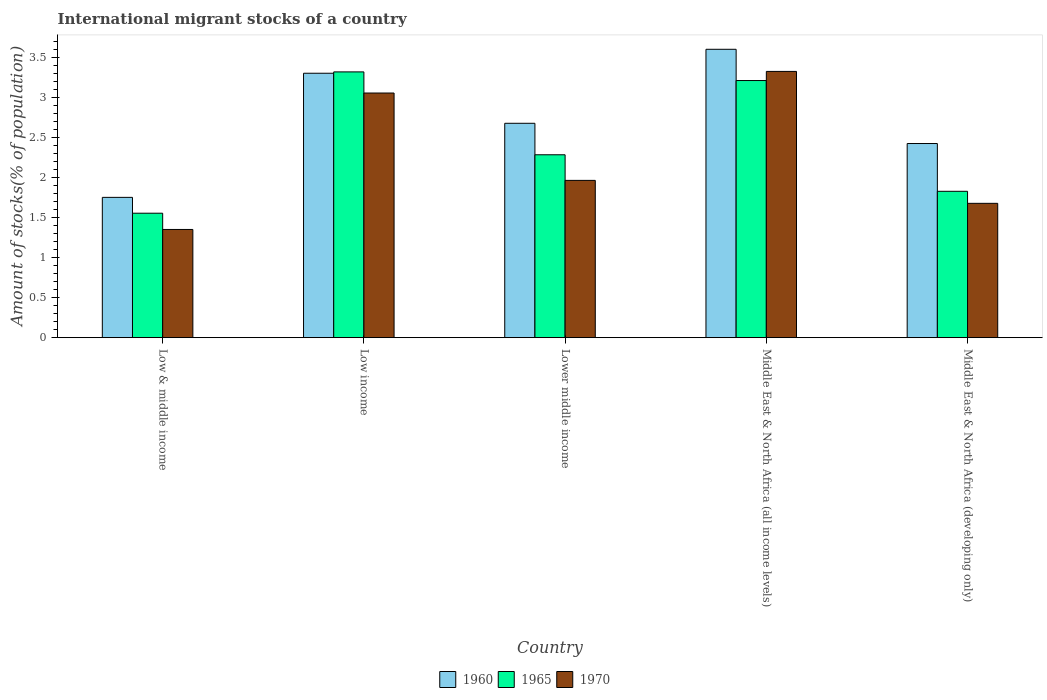How many groups of bars are there?
Give a very brief answer. 5. How many bars are there on the 5th tick from the right?
Provide a succinct answer. 3. In how many cases, is the number of bars for a given country not equal to the number of legend labels?
Offer a very short reply. 0. What is the amount of stocks in in 1965 in Low & middle income?
Your answer should be very brief. 1.56. Across all countries, what is the maximum amount of stocks in in 1970?
Provide a short and direct response. 3.33. Across all countries, what is the minimum amount of stocks in in 1965?
Offer a terse response. 1.56. In which country was the amount of stocks in in 1960 maximum?
Provide a succinct answer. Middle East & North Africa (all income levels). In which country was the amount of stocks in in 1970 minimum?
Your answer should be compact. Low & middle income. What is the total amount of stocks in in 1970 in the graph?
Offer a very short reply. 11.38. What is the difference between the amount of stocks in in 1965 in Lower middle income and that in Middle East & North Africa (all income levels)?
Provide a succinct answer. -0.93. What is the difference between the amount of stocks in in 1970 in Low & middle income and the amount of stocks in in 1965 in Low income?
Offer a terse response. -1.97. What is the average amount of stocks in in 1960 per country?
Your answer should be very brief. 2.75. What is the difference between the amount of stocks in of/in 1960 and amount of stocks in of/in 1970 in Middle East & North Africa (all income levels)?
Your answer should be compact. 0.28. In how many countries, is the amount of stocks in in 1965 greater than 2.1 %?
Your response must be concise. 3. What is the ratio of the amount of stocks in in 1970 in Middle East & North Africa (all income levels) to that in Middle East & North Africa (developing only)?
Offer a terse response. 1.98. What is the difference between the highest and the second highest amount of stocks in in 1960?
Offer a terse response. 0.63. What is the difference between the highest and the lowest amount of stocks in in 1970?
Offer a terse response. 1.98. What does the 2nd bar from the left in Low & middle income represents?
Provide a succinct answer. 1965. What does the 2nd bar from the right in Middle East & North Africa (all income levels) represents?
Offer a very short reply. 1965. Is it the case that in every country, the sum of the amount of stocks in in 1960 and amount of stocks in in 1970 is greater than the amount of stocks in in 1965?
Keep it short and to the point. Yes. How many bars are there?
Ensure brevity in your answer.  15. What is the difference between two consecutive major ticks on the Y-axis?
Give a very brief answer. 0.5. Does the graph contain grids?
Your answer should be compact. No. What is the title of the graph?
Your answer should be compact. International migrant stocks of a country. Does "2004" appear as one of the legend labels in the graph?
Provide a short and direct response. No. What is the label or title of the X-axis?
Provide a short and direct response. Country. What is the label or title of the Y-axis?
Provide a short and direct response. Amount of stocks(% of population). What is the Amount of stocks(% of population) of 1960 in Low & middle income?
Keep it short and to the point. 1.75. What is the Amount of stocks(% of population) in 1965 in Low & middle income?
Make the answer very short. 1.56. What is the Amount of stocks(% of population) of 1970 in Low & middle income?
Offer a terse response. 1.35. What is the Amount of stocks(% of population) of 1960 in Low income?
Provide a succinct answer. 3.31. What is the Amount of stocks(% of population) of 1965 in Low income?
Your answer should be very brief. 3.32. What is the Amount of stocks(% of population) in 1970 in Low income?
Your response must be concise. 3.06. What is the Amount of stocks(% of population) of 1960 in Lower middle income?
Keep it short and to the point. 2.68. What is the Amount of stocks(% of population) in 1965 in Lower middle income?
Your response must be concise. 2.29. What is the Amount of stocks(% of population) of 1970 in Lower middle income?
Your response must be concise. 1.97. What is the Amount of stocks(% of population) in 1960 in Middle East & North Africa (all income levels)?
Make the answer very short. 3.6. What is the Amount of stocks(% of population) of 1965 in Middle East & North Africa (all income levels)?
Offer a very short reply. 3.21. What is the Amount of stocks(% of population) in 1970 in Middle East & North Africa (all income levels)?
Offer a terse response. 3.33. What is the Amount of stocks(% of population) in 1960 in Middle East & North Africa (developing only)?
Offer a very short reply. 2.43. What is the Amount of stocks(% of population) of 1965 in Middle East & North Africa (developing only)?
Offer a terse response. 1.83. What is the Amount of stocks(% of population) of 1970 in Middle East & North Africa (developing only)?
Provide a succinct answer. 1.68. Across all countries, what is the maximum Amount of stocks(% of population) of 1960?
Offer a terse response. 3.6. Across all countries, what is the maximum Amount of stocks(% of population) of 1965?
Provide a succinct answer. 3.32. Across all countries, what is the maximum Amount of stocks(% of population) of 1970?
Keep it short and to the point. 3.33. Across all countries, what is the minimum Amount of stocks(% of population) in 1960?
Ensure brevity in your answer.  1.75. Across all countries, what is the minimum Amount of stocks(% of population) in 1965?
Provide a succinct answer. 1.56. Across all countries, what is the minimum Amount of stocks(% of population) of 1970?
Offer a terse response. 1.35. What is the total Amount of stocks(% of population) of 1960 in the graph?
Provide a succinct answer. 13.77. What is the total Amount of stocks(% of population) of 1965 in the graph?
Your response must be concise. 12.21. What is the total Amount of stocks(% of population) in 1970 in the graph?
Offer a terse response. 11.38. What is the difference between the Amount of stocks(% of population) in 1960 in Low & middle income and that in Low income?
Provide a succinct answer. -1.55. What is the difference between the Amount of stocks(% of population) in 1965 in Low & middle income and that in Low income?
Your answer should be compact. -1.77. What is the difference between the Amount of stocks(% of population) of 1970 in Low & middle income and that in Low income?
Provide a succinct answer. -1.71. What is the difference between the Amount of stocks(% of population) in 1960 in Low & middle income and that in Lower middle income?
Provide a short and direct response. -0.93. What is the difference between the Amount of stocks(% of population) of 1965 in Low & middle income and that in Lower middle income?
Offer a terse response. -0.73. What is the difference between the Amount of stocks(% of population) in 1970 in Low & middle income and that in Lower middle income?
Offer a very short reply. -0.61. What is the difference between the Amount of stocks(% of population) in 1960 in Low & middle income and that in Middle East & North Africa (all income levels)?
Your response must be concise. -1.85. What is the difference between the Amount of stocks(% of population) of 1965 in Low & middle income and that in Middle East & North Africa (all income levels)?
Offer a terse response. -1.66. What is the difference between the Amount of stocks(% of population) in 1970 in Low & middle income and that in Middle East & North Africa (all income levels)?
Keep it short and to the point. -1.98. What is the difference between the Amount of stocks(% of population) in 1960 in Low & middle income and that in Middle East & North Africa (developing only)?
Give a very brief answer. -0.67. What is the difference between the Amount of stocks(% of population) in 1965 in Low & middle income and that in Middle East & North Africa (developing only)?
Give a very brief answer. -0.27. What is the difference between the Amount of stocks(% of population) in 1970 in Low & middle income and that in Middle East & North Africa (developing only)?
Ensure brevity in your answer.  -0.33. What is the difference between the Amount of stocks(% of population) of 1960 in Low income and that in Lower middle income?
Give a very brief answer. 0.63. What is the difference between the Amount of stocks(% of population) of 1965 in Low income and that in Lower middle income?
Make the answer very short. 1.04. What is the difference between the Amount of stocks(% of population) of 1970 in Low income and that in Lower middle income?
Your answer should be compact. 1.09. What is the difference between the Amount of stocks(% of population) of 1960 in Low income and that in Middle East & North Africa (all income levels)?
Your answer should be compact. -0.3. What is the difference between the Amount of stocks(% of population) in 1965 in Low income and that in Middle East & North Africa (all income levels)?
Make the answer very short. 0.11. What is the difference between the Amount of stocks(% of population) in 1970 in Low income and that in Middle East & North Africa (all income levels)?
Offer a very short reply. -0.27. What is the difference between the Amount of stocks(% of population) of 1960 in Low income and that in Middle East & North Africa (developing only)?
Your response must be concise. 0.88. What is the difference between the Amount of stocks(% of population) of 1965 in Low income and that in Middle East & North Africa (developing only)?
Your answer should be compact. 1.49. What is the difference between the Amount of stocks(% of population) of 1970 in Low income and that in Middle East & North Africa (developing only)?
Offer a very short reply. 1.38. What is the difference between the Amount of stocks(% of population) of 1960 in Lower middle income and that in Middle East & North Africa (all income levels)?
Offer a terse response. -0.93. What is the difference between the Amount of stocks(% of population) in 1965 in Lower middle income and that in Middle East & North Africa (all income levels)?
Keep it short and to the point. -0.93. What is the difference between the Amount of stocks(% of population) in 1970 in Lower middle income and that in Middle East & North Africa (all income levels)?
Provide a short and direct response. -1.36. What is the difference between the Amount of stocks(% of population) of 1960 in Lower middle income and that in Middle East & North Africa (developing only)?
Provide a succinct answer. 0.25. What is the difference between the Amount of stocks(% of population) of 1965 in Lower middle income and that in Middle East & North Africa (developing only)?
Ensure brevity in your answer.  0.46. What is the difference between the Amount of stocks(% of population) in 1970 in Lower middle income and that in Middle East & North Africa (developing only)?
Make the answer very short. 0.29. What is the difference between the Amount of stocks(% of population) of 1960 in Middle East & North Africa (all income levels) and that in Middle East & North Africa (developing only)?
Provide a succinct answer. 1.18. What is the difference between the Amount of stocks(% of population) of 1965 in Middle East & North Africa (all income levels) and that in Middle East & North Africa (developing only)?
Keep it short and to the point. 1.38. What is the difference between the Amount of stocks(% of population) in 1970 in Middle East & North Africa (all income levels) and that in Middle East & North Africa (developing only)?
Ensure brevity in your answer.  1.65. What is the difference between the Amount of stocks(% of population) in 1960 in Low & middle income and the Amount of stocks(% of population) in 1965 in Low income?
Provide a short and direct response. -1.57. What is the difference between the Amount of stocks(% of population) in 1960 in Low & middle income and the Amount of stocks(% of population) in 1970 in Low income?
Keep it short and to the point. -1.3. What is the difference between the Amount of stocks(% of population) of 1965 in Low & middle income and the Amount of stocks(% of population) of 1970 in Low income?
Offer a very short reply. -1.5. What is the difference between the Amount of stocks(% of population) in 1960 in Low & middle income and the Amount of stocks(% of population) in 1965 in Lower middle income?
Provide a short and direct response. -0.53. What is the difference between the Amount of stocks(% of population) in 1960 in Low & middle income and the Amount of stocks(% of population) in 1970 in Lower middle income?
Make the answer very short. -0.21. What is the difference between the Amount of stocks(% of population) of 1965 in Low & middle income and the Amount of stocks(% of population) of 1970 in Lower middle income?
Give a very brief answer. -0.41. What is the difference between the Amount of stocks(% of population) in 1960 in Low & middle income and the Amount of stocks(% of population) in 1965 in Middle East & North Africa (all income levels)?
Provide a short and direct response. -1.46. What is the difference between the Amount of stocks(% of population) in 1960 in Low & middle income and the Amount of stocks(% of population) in 1970 in Middle East & North Africa (all income levels)?
Provide a short and direct response. -1.57. What is the difference between the Amount of stocks(% of population) of 1965 in Low & middle income and the Amount of stocks(% of population) of 1970 in Middle East & North Africa (all income levels)?
Keep it short and to the point. -1.77. What is the difference between the Amount of stocks(% of population) in 1960 in Low & middle income and the Amount of stocks(% of population) in 1965 in Middle East & North Africa (developing only)?
Offer a terse response. -0.08. What is the difference between the Amount of stocks(% of population) of 1960 in Low & middle income and the Amount of stocks(% of population) of 1970 in Middle East & North Africa (developing only)?
Offer a terse response. 0.07. What is the difference between the Amount of stocks(% of population) in 1965 in Low & middle income and the Amount of stocks(% of population) in 1970 in Middle East & North Africa (developing only)?
Offer a terse response. -0.12. What is the difference between the Amount of stocks(% of population) of 1960 in Low income and the Amount of stocks(% of population) of 1965 in Lower middle income?
Your response must be concise. 1.02. What is the difference between the Amount of stocks(% of population) of 1960 in Low income and the Amount of stocks(% of population) of 1970 in Lower middle income?
Give a very brief answer. 1.34. What is the difference between the Amount of stocks(% of population) of 1965 in Low income and the Amount of stocks(% of population) of 1970 in Lower middle income?
Offer a terse response. 1.36. What is the difference between the Amount of stocks(% of population) of 1960 in Low income and the Amount of stocks(% of population) of 1965 in Middle East & North Africa (all income levels)?
Offer a very short reply. 0.09. What is the difference between the Amount of stocks(% of population) in 1960 in Low income and the Amount of stocks(% of population) in 1970 in Middle East & North Africa (all income levels)?
Keep it short and to the point. -0.02. What is the difference between the Amount of stocks(% of population) in 1965 in Low income and the Amount of stocks(% of population) in 1970 in Middle East & North Africa (all income levels)?
Offer a very short reply. -0.01. What is the difference between the Amount of stocks(% of population) in 1960 in Low income and the Amount of stocks(% of population) in 1965 in Middle East & North Africa (developing only)?
Provide a short and direct response. 1.48. What is the difference between the Amount of stocks(% of population) of 1960 in Low income and the Amount of stocks(% of population) of 1970 in Middle East & North Africa (developing only)?
Keep it short and to the point. 1.63. What is the difference between the Amount of stocks(% of population) of 1965 in Low income and the Amount of stocks(% of population) of 1970 in Middle East & North Africa (developing only)?
Your response must be concise. 1.64. What is the difference between the Amount of stocks(% of population) in 1960 in Lower middle income and the Amount of stocks(% of population) in 1965 in Middle East & North Africa (all income levels)?
Keep it short and to the point. -0.53. What is the difference between the Amount of stocks(% of population) of 1960 in Lower middle income and the Amount of stocks(% of population) of 1970 in Middle East & North Africa (all income levels)?
Provide a short and direct response. -0.65. What is the difference between the Amount of stocks(% of population) in 1965 in Lower middle income and the Amount of stocks(% of population) in 1970 in Middle East & North Africa (all income levels)?
Your answer should be compact. -1.04. What is the difference between the Amount of stocks(% of population) in 1960 in Lower middle income and the Amount of stocks(% of population) in 1965 in Middle East & North Africa (developing only)?
Your answer should be compact. 0.85. What is the difference between the Amount of stocks(% of population) in 1960 in Lower middle income and the Amount of stocks(% of population) in 1970 in Middle East & North Africa (developing only)?
Your response must be concise. 1. What is the difference between the Amount of stocks(% of population) of 1965 in Lower middle income and the Amount of stocks(% of population) of 1970 in Middle East & North Africa (developing only)?
Ensure brevity in your answer.  0.61. What is the difference between the Amount of stocks(% of population) in 1960 in Middle East & North Africa (all income levels) and the Amount of stocks(% of population) in 1965 in Middle East & North Africa (developing only)?
Offer a terse response. 1.78. What is the difference between the Amount of stocks(% of population) of 1960 in Middle East & North Africa (all income levels) and the Amount of stocks(% of population) of 1970 in Middle East & North Africa (developing only)?
Offer a terse response. 1.93. What is the difference between the Amount of stocks(% of population) of 1965 in Middle East & North Africa (all income levels) and the Amount of stocks(% of population) of 1970 in Middle East & North Africa (developing only)?
Your answer should be compact. 1.53. What is the average Amount of stocks(% of population) of 1960 per country?
Give a very brief answer. 2.75. What is the average Amount of stocks(% of population) of 1965 per country?
Provide a short and direct response. 2.44. What is the average Amount of stocks(% of population) in 1970 per country?
Make the answer very short. 2.28. What is the difference between the Amount of stocks(% of population) of 1960 and Amount of stocks(% of population) of 1965 in Low & middle income?
Ensure brevity in your answer.  0.2. What is the difference between the Amount of stocks(% of population) of 1960 and Amount of stocks(% of population) of 1970 in Low & middle income?
Make the answer very short. 0.4. What is the difference between the Amount of stocks(% of population) of 1965 and Amount of stocks(% of population) of 1970 in Low & middle income?
Give a very brief answer. 0.2. What is the difference between the Amount of stocks(% of population) in 1960 and Amount of stocks(% of population) in 1965 in Low income?
Provide a short and direct response. -0.02. What is the difference between the Amount of stocks(% of population) in 1960 and Amount of stocks(% of population) in 1970 in Low income?
Keep it short and to the point. 0.25. What is the difference between the Amount of stocks(% of population) of 1965 and Amount of stocks(% of population) of 1970 in Low income?
Offer a terse response. 0.26. What is the difference between the Amount of stocks(% of population) of 1960 and Amount of stocks(% of population) of 1965 in Lower middle income?
Ensure brevity in your answer.  0.39. What is the difference between the Amount of stocks(% of population) in 1960 and Amount of stocks(% of population) in 1970 in Lower middle income?
Offer a terse response. 0.71. What is the difference between the Amount of stocks(% of population) in 1965 and Amount of stocks(% of population) in 1970 in Lower middle income?
Ensure brevity in your answer.  0.32. What is the difference between the Amount of stocks(% of population) of 1960 and Amount of stocks(% of population) of 1965 in Middle East & North Africa (all income levels)?
Keep it short and to the point. 0.39. What is the difference between the Amount of stocks(% of population) in 1960 and Amount of stocks(% of population) in 1970 in Middle East & North Africa (all income levels)?
Keep it short and to the point. 0.28. What is the difference between the Amount of stocks(% of population) in 1965 and Amount of stocks(% of population) in 1970 in Middle East & North Africa (all income levels)?
Make the answer very short. -0.11. What is the difference between the Amount of stocks(% of population) in 1960 and Amount of stocks(% of population) in 1965 in Middle East & North Africa (developing only)?
Make the answer very short. 0.6. What is the difference between the Amount of stocks(% of population) in 1960 and Amount of stocks(% of population) in 1970 in Middle East & North Africa (developing only)?
Provide a succinct answer. 0.75. What is the difference between the Amount of stocks(% of population) in 1965 and Amount of stocks(% of population) in 1970 in Middle East & North Africa (developing only)?
Offer a terse response. 0.15. What is the ratio of the Amount of stocks(% of population) in 1960 in Low & middle income to that in Low income?
Offer a terse response. 0.53. What is the ratio of the Amount of stocks(% of population) of 1965 in Low & middle income to that in Low income?
Make the answer very short. 0.47. What is the ratio of the Amount of stocks(% of population) of 1970 in Low & middle income to that in Low income?
Your answer should be compact. 0.44. What is the ratio of the Amount of stocks(% of population) of 1960 in Low & middle income to that in Lower middle income?
Your answer should be compact. 0.65. What is the ratio of the Amount of stocks(% of population) in 1965 in Low & middle income to that in Lower middle income?
Your answer should be compact. 0.68. What is the ratio of the Amount of stocks(% of population) of 1970 in Low & middle income to that in Lower middle income?
Your response must be concise. 0.69. What is the ratio of the Amount of stocks(% of population) of 1960 in Low & middle income to that in Middle East & North Africa (all income levels)?
Provide a short and direct response. 0.49. What is the ratio of the Amount of stocks(% of population) in 1965 in Low & middle income to that in Middle East & North Africa (all income levels)?
Give a very brief answer. 0.48. What is the ratio of the Amount of stocks(% of population) of 1970 in Low & middle income to that in Middle East & North Africa (all income levels)?
Ensure brevity in your answer.  0.41. What is the ratio of the Amount of stocks(% of population) in 1960 in Low & middle income to that in Middle East & North Africa (developing only)?
Offer a very short reply. 0.72. What is the ratio of the Amount of stocks(% of population) in 1965 in Low & middle income to that in Middle East & North Africa (developing only)?
Give a very brief answer. 0.85. What is the ratio of the Amount of stocks(% of population) in 1970 in Low & middle income to that in Middle East & North Africa (developing only)?
Make the answer very short. 0.81. What is the ratio of the Amount of stocks(% of population) in 1960 in Low income to that in Lower middle income?
Your answer should be compact. 1.23. What is the ratio of the Amount of stocks(% of population) in 1965 in Low income to that in Lower middle income?
Provide a short and direct response. 1.45. What is the ratio of the Amount of stocks(% of population) in 1970 in Low income to that in Lower middle income?
Give a very brief answer. 1.56. What is the ratio of the Amount of stocks(% of population) in 1960 in Low income to that in Middle East & North Africa (all income levels)?
Make the answer very short. 0.92. What is the ratio of the Amount of stocks(% of population) in 1965 in Low income to that in Middle East & North Africa (all income levels)?
Provide a short and direct response. 1.03. What is the ratio of the Amount of stocks(% of population) of 1970 in Low income to that in Middle East & North Africa (all income levels)?
Provide a short and direct response. 0.92. What is the ratio of the Amount of stocks(% of population) in 1960 in Low income to that in Middle East & North Africa (developing only)?
Provide a succinct answer. 1.36. What is the ratio of the Amount of stocks(% of population) in 1965 in Low income to that in Middle East & North Africa (developing only)?
Provide a succinct answer. 1.82. What is the ratio of the Amount of stocks(% of population) of 1970 in Low income to that in Middle East & North Africa (developing only)?
Make the answer very short. 1.82. What is the ratio of the Amount of stocks(% of population) of 1960 in Lower middle income to that in Middle East & North Africa (all income levels)?
Keep it short and to the point. 0.74. What is the ratio of the Amount of stocks(% of population) of 1965 in Lower middle income to that in Middle East & North Africa (all income levels)?
Your response must be concise. 0.71. What is the ratio of the Amount of stocks(% of population) in 1970 in Lower middle income to that in Middle East & North Africa (all income levels)?
Your answer should be compact. 0.59. What is the ratio of the Amount of stocks(% of population) of 1960 in Lower middle income to that in Middle East & North Africa (developing only)?
Offer a very short reply. 1.1. What is the ratio of the Amount of stocks(% of population) in 1965 in Lower middle income to that in Middle East & North Africa (developing only)?
Your answer should be compact. 1.25. What is the ratio of the Amount of stocks(% of population) of 1970 in Lower middle income to that in Middle East & North Africa (developing only)?
Offer a very short reply. 1.17. What is the ratio of the Amount of stocks(% of population) of 1960 in Middle East & North Africa (all income levels) to that in Middle East & North Africa (developing only)?
Make the answer very short. 1.49. What is the ratio of the Amount of stocks(% of population) in 1965 in Middle East & North Africa (all income levels) to that in Middle East & North Africa (developing only)?
Offer a very short reply. 1.76. What is the ratio of the Amount of stocks(% of population) of 1970 in Middle East & North Africa (all income levels) to that in Middle East & North Africa (developing only)?
Provide a succinct answer. 1.98. What is the difference between the highest and the second highest Amount of stocks(% of population) in 1960?
Your answer should be very brief. 0.3. What is the difference between the highest and the second highest Amount of stocks(% of population) in 1965?
Provide a short and direct response. 0.11. What is the difference between the highest and the second highest Amount of stocks(% of population) in 1970?
Offer a terse response. 0.27. What is the difference between the highest and the lowest Amount of stocks(% of population) of 1960?
Provide a short and direct response. 1.85. What is the difference between the highest and the lowest Amount of stocks(% of population) in 1965?
Offer a terse response. 1.77. What is the difference between the highest and the lowest Amount of stocks(% of population) in 1970?
Your answer should be very brief. 1.98. 